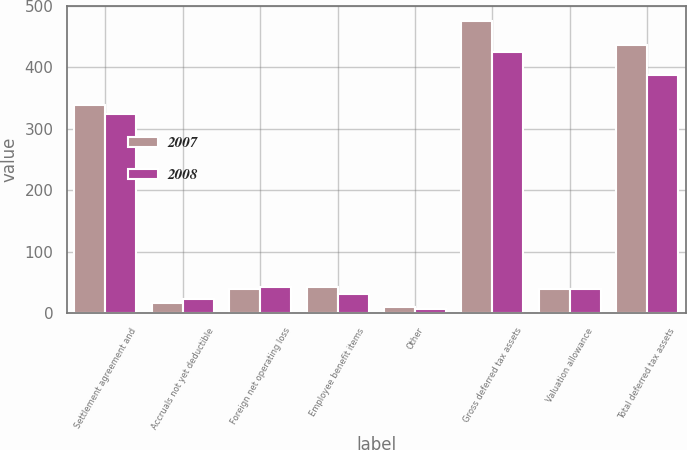<chart> <loc_0><loc_0><loc_500><loc_500><stacked_bar_chart><ecel><fcel>Settlement agreement and<fcel>Accruals not yet deductible<fcel>Foreign net operating loss<fcel>Employee benefit items<fcel>Other<fcel>Gross deferred tax assets<fcel>Valuation allowance<fcel>Total deferred tax assets<nl><fcel>2007<fcel>339.5<fcel>16.1<fcel>39.9<fcel>42.2<fcel>10.1<fcel>476.3<fcel>39.9<fcel>436.4<nl><fcel>2008<fcel>323.5<fcel>22.9<fcel>42.4<fcel>30.3<fcel>6.7<fcel>425.8<fcel>38.4<fcel>387.4<nl></chart> 